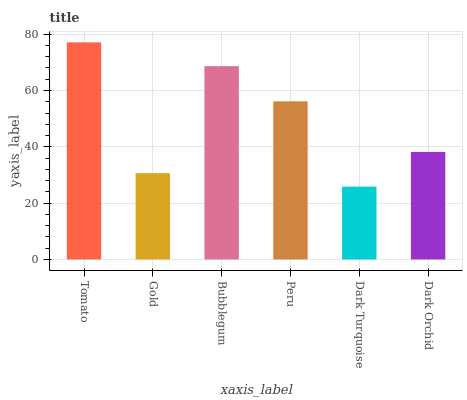Is Dark Turquoise the minimum?
Answer yes or no. Yes. Is Tomato the maximum?
Answer yes or no. Yes. Is Gold the minimum?
Answer yes or no. No. Is Gold the maximum?
Answer yes or no. No. Is Tomato greater than Gold?
Answer yes or no. Yes. Is Gold less than Tomato?
Answer yes or no. Yes. Is Gold greater than Tomato?
Answer yes or no. No. Is Tomato less than Gold?
Answer yes or no. No. Is Peru the high median?
Answer yes or no. Yes. Is Dark Orchid the low median?
Answer yes or no. Yes. Is Gold the high median?
Answer yes or no. No. Is Dark Turquoise the low median?
Answer yes or no. No. 